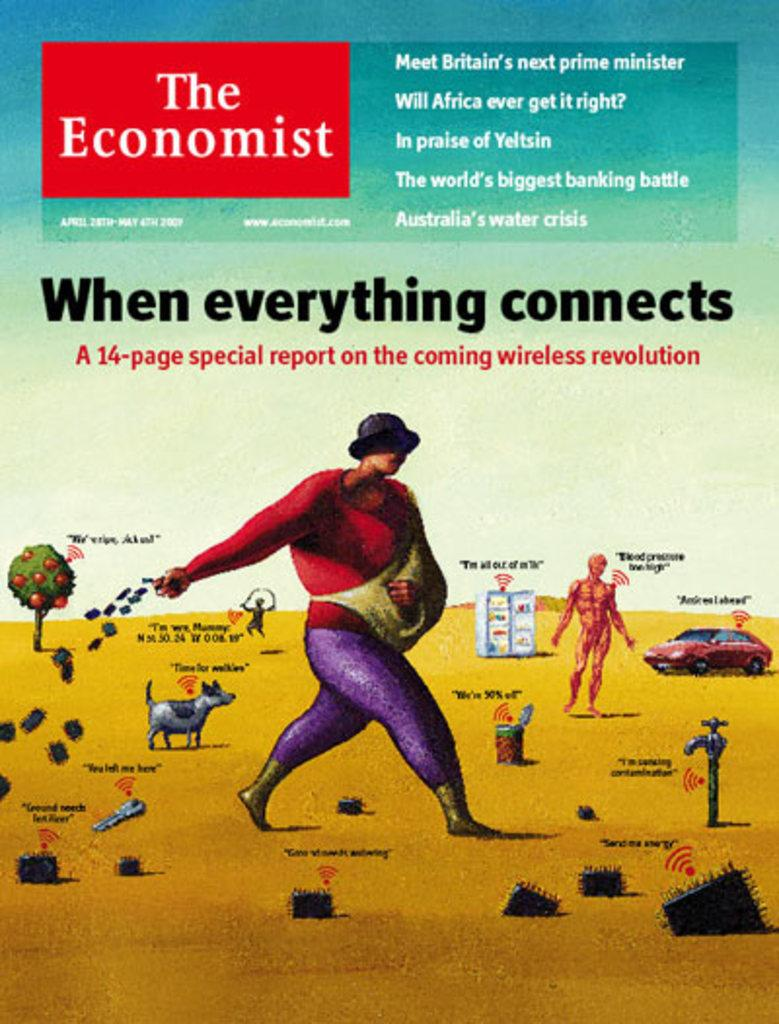<image>
Give a short and clear explanation of the subsequent image. An issue of The Economist magazine has the headline When everything connects. 